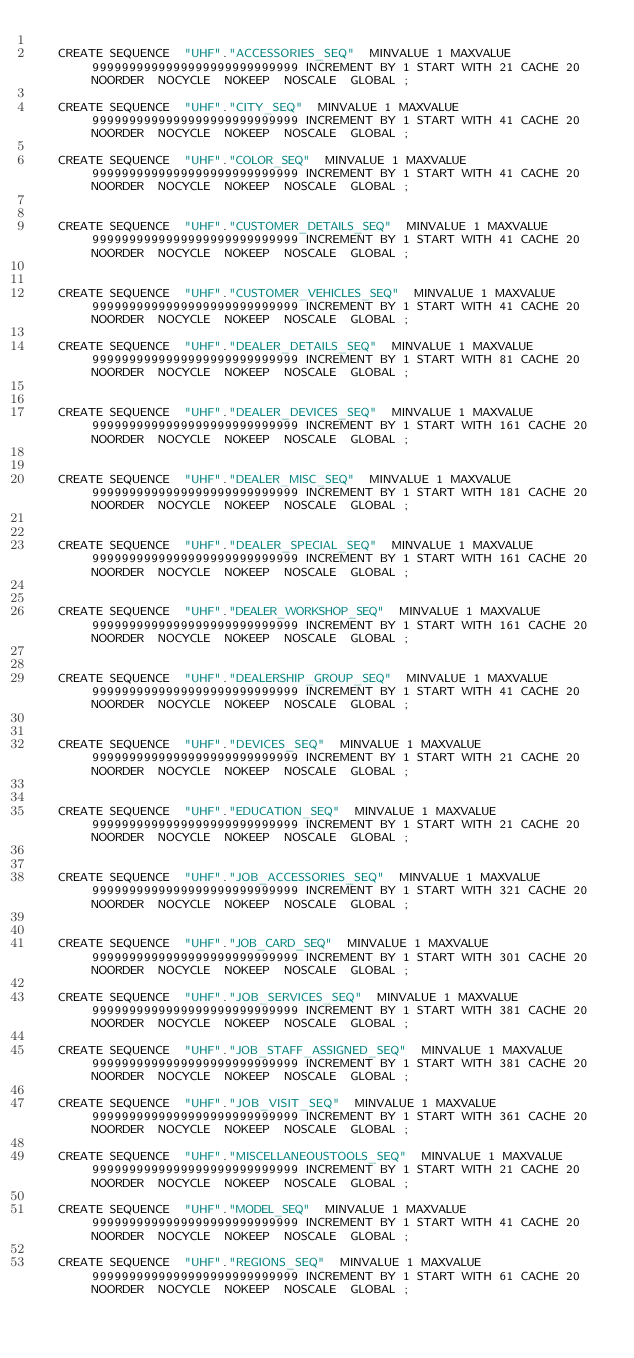<code> <loc_0><loc_0><loc_500><loc_500><_SQL_>
   CREATE SEQUENCE  "UHF"."ACCESSORIES_SEQ"  MINVALUE 1 MAXVALUE 9999999999999999999999999999 INCREMENT BY 1 START WITH 21 CACHE 20 NOORDER  NOCYCLE  NOKEEP  NOSCALE  GLOBAL ;

   CREATE SEQUENCE  "UHF"."CITY_SEQ"  MINVALUE 1 MAXVALUE 9999999999999999999999999999 INCREMENT BY 1 START WITH 41 CACHE 20 NOORDER  NOCYCLE  NOKEEP  NOSCALE  GLOBAL ;

   CREATE SEQUENCE  "UHF"."COLOR_SEQ"  MINVALUE 1 MAXVALUE 9999999999999999999999999999 INCREMENT BY 1 START WITH 41 CACHE 20 NOORDER  NOCYCLE  NOKEEP  NOSCALE  GLOBAL ;


   CREATE SEQUENCE  "UHF"."CUSTOMER_DETAILS_SEQ"  MINVALUE 1 MAXVALUE 9999999999999999999999999999 INCREMENT BY 1 START WITH 41 CACHE 20 NOORDER  NOCYCLE  NOKEEP  NOSCALE  GLOBAL ;


   CREATE SEQUENCE  "UHF"."CUSTOMER_VEHICLES_SEQ"  MINVALUE 1 MAXVALUE 9999999999999999999999999999 INCREMENT BY 1 START WITH 41 CACHE 20 NOORDER  NOCYCLE  NOKEEP  NOSCALE  GLOBAL ;

   CREATE SEQUENCE  "UHF"."DEALER_DETAILS_SEQ"  MINVALUE 1 MAXVALUE 9999999999999999999999999999 INCREMENT BY 1 START WITH 81 CACHE 20 NOORDER  NOCYCLE  NOKEEP  NOSCALE  GLOBAL ;


   CREATE SEQUENCE  "UHF"."DEALER_DEVICES_SEQ"  MINVALUE 1 MAXVALUE 9999999999999999999999999999 INCREMENT BY 1 START WITH 161 CACHE 20 NOORDER  NOCYCLE  NOKEEP  NOSCALE  GLOBAL ;


   CREATE SEQUENCE  "UHF"."DEALER_MISC_SEQ"  MINVALUE 1 MAXVALUE 9999999999999999999999999999 INCREMENT BY 1 START WITH 181 CACHE 20 NOORDER  NOCYCLE  NOKEEP  NOSCALE  GLOBAL ;


   CREATE SEQUENCE  "UHF"."DEALER_SPECIAL_SEQ"  MINVALUE 1 MAXVALUE 9999999999999999999999999999 INCREMENT BY 1 START WITH 161 CACHE 20 NOORDER  NOCYCLE  NOKEEP  NOSCALE  GLOBAL ;


   CREATE SEQUENCE  "UHF"."DEALER_WORKSHOP_SEQ"  MINVALUE 1 MAXVALUE 9999999999999999999999999999 INCREMENT BY 1 START WITH 161 CACHE 20 NOORDER  NOCYCLE  NOKEEP  NOSCALE  GLOBAL ;


   CREATE SEQUENCE  "UHF"."DEALERSHIP_GROUP_SEQ"  MINVALUE 1 MAXVALUE 9999999999999999999999999999 INCREMENT BY 1 START WITH 41 CACHE 20 NOORDER  NOCYCLE  NOKEEP  NOSCALE  GLOBAL ;


   CREATE SEQUENCE  "UHF"."DEVICES_SEQ"  MINVALUE 1 MAXVALUE 9999999999999999999999999999 INCREMENT BY 1 START WITH 21 CACHE 20 NOORDER  NOCYCLE  NOKEEP  NOSCALE  GLOBAL ;


   CREATE SEQUENCE  "UHF"."EDUCATION_SEQ"  MINVALUE 1 MAXVALUE 9999999999999999999999999999 INCREMENT BY 1 START WITH 21 CACHE 20 NOORDER  NOCYCLE  NOKEEP  NOSCALE  GLOBAL ;


   CREATE SEQUENCE  "UHF"."JOB_ACCESSORIES_SEQ"  MINVALUE 1 MAXVALUE 9999999999999999999999999999 INCREMENT BY 1 START WITH 321 CACHE 20 NOORDER  NOCYCLE  NOKEEP  NOSCALE  GLOBAL ;


   CREATE SEQUENCE  "UHF"."JOB_CARD_SEQ"  MINVALUE 1 MAXVALUE 9999999999999999999999999999 INCREMENT BY 1 START WITH 301 CACHE 20 NOORDER  NOCYCLE  NOKEEP  NOSCALE  GLOBAL ;

   CREATE SEQUENCE  "UHF"."JOB_SERVICES_SEQ"  MINVALUE 1 MAXVALUE 9999999999999999999999999999 INCREMENT BY 1 START WITH 381 CACHE 20 NOORDER  NOCYCLE  NOKEEP  NOSCALE  GLOBAL ;

   CREATE SEQUENCE  "UHF"."JOB_STAFF_ASSIGNED_SEQ"  MINVALUE 1 MAXVALUE 9999999999999999999999999999 INCREMENT BY 1 START WITH 381 CACHE 20 NOORDER  NOCYCLE  NOKEEP  NOSCALE  GLOBAL ;

   CREATE SEQUENCE  "UHF"."JOB_VISIT_SEQ"  MINVALUE 1 MAXVALUE 9999999999999999999999999999 INCREMENT BY 1 START WITH 361 CACHE 20 NOORDER  NOCYCLE  NOKEEP  NOSCALE  GLOBAL ;

   CREATE SEQUENCE  "UHF"."MISCELLANEOUSTOOLS_SEQ"  MINVALUE 1 MAXVALUE 9999999999999999999999999999 INCREMENT BY 1 START WITH 21 CACHE 20 NOORDER  NOCYCLE  NOKEEP  NOSCALE  GLOBAL ;

   CREATE SEQUENCE  "UHF"."MODEL_SEQ"  MINVALUE 1 MAXVALUE 9999999999999999999999999999 INCREMENT BY 1 START WITH 41 CACHE 20 NOORDER  NOCYCLE  NOKEEP  NOSCALE  GLOBAL ;

   CREATE SEQUENCE  "UHF"."REGIONS_SEQ"  MINVALUE 1 MAXVALUE 9999999999999999999999999999 INCREMENT BY 1 START WITH 61 CACHE 20 NOORDER  NOCYCLE  NOKEEP  NOSCALE  GLOBAL ;
</code> 